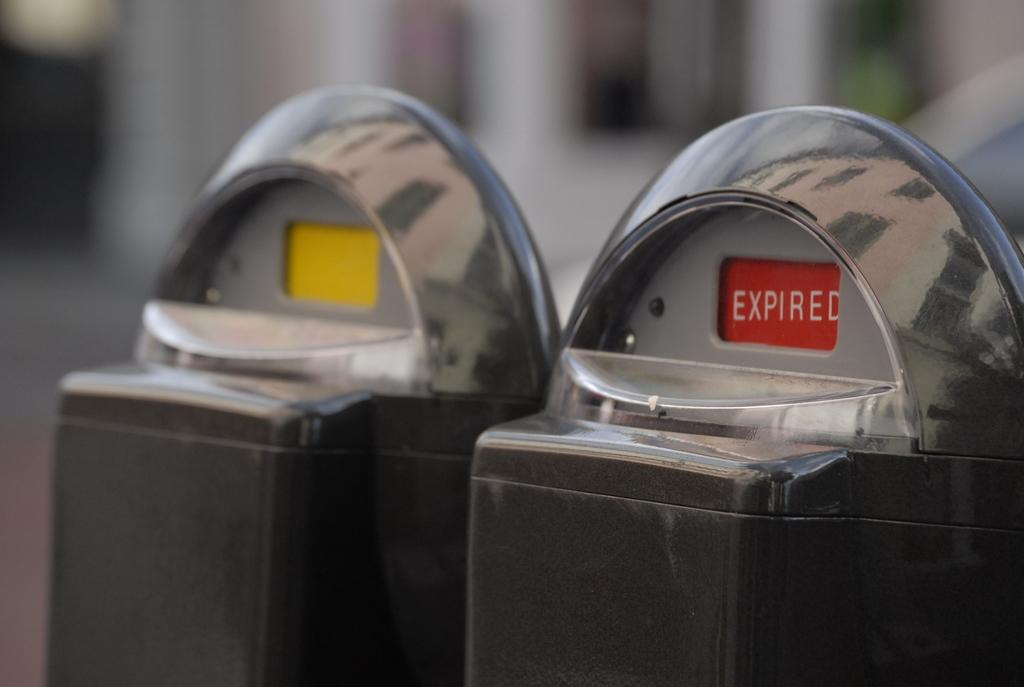<image>
Provide a brief description of the given image. Parking meter that says Expired in red next to one with nothing on the screen. 